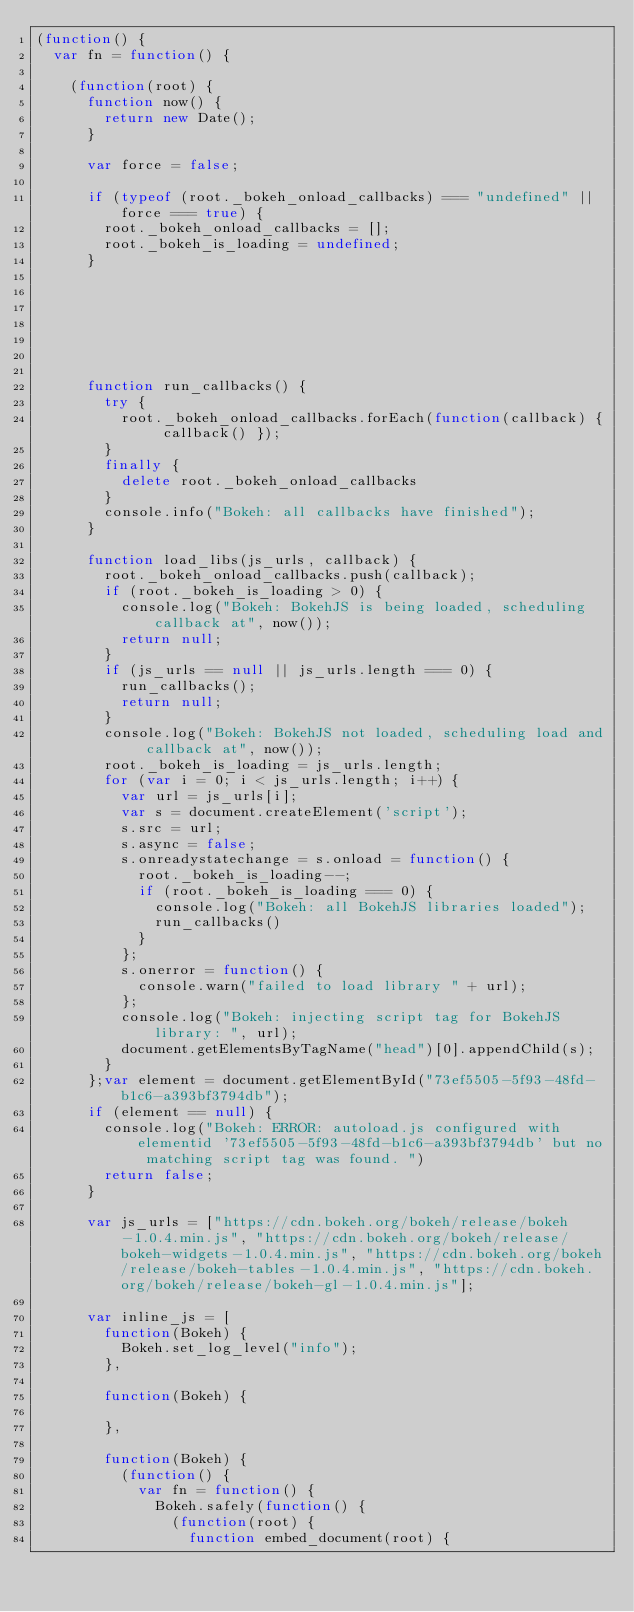<code> <loc_0><loc_0><loc_500><loc_500><_JavaScript_>(function() {
  var fn = function() {
    
    (function(root) {
      function now() {
        return new Date();
      }
    
      var force = false;
    
      if (typeof (root._bokeh_onload_callbacks) === "undefined" || force === true) {
        root._bokeh_onload_callbacks = [];
        root._bokeh_is_loading = undefined;
      }
    
      
      
    
      
      
    
      function run_callbacks() {
        try {
          root._bokeh_onload_callbacks.forEach(function(callback) { callback() });
        }
        finally {
          delete root._bokeh_onload_callbacks
        }
        console.info("Bokeh: all callbacks have finished");
      }
    
      function load_libs(js_urls, callback) {
        root._bokeh_onload_callbacks.push(callback);
        if (root._bokeh_is_loading > 0) {
          console.log("Bokeh: BokehJS is being loaded, scheduling callback at", now());
          return null;
        }
        if (js_urls == null || js_urls.length === 0) {
          run_callbacks();
          return null;
        }
        console.log("Bokeh: BokehJS not loaded, scheduling load and callback at", now());
        root._bokeh_is_loading = js_urls.length;
        for (var i = 0; i < js_urls.length; i++) {
          var url = js_urls[i];
          var s = document.createElement('script');
          s.src = url;
          s.async = false;
          s.onreadystatechange = s.onload = function() {
            root._bokeh_is_loading--;
            if (root._bokeh_is_loading === 0) {
              console.log("Bokeh: all BokehJS libraries loaded");
              run_callbacks()
            }
          };
          s.onerror = function() {
            console.warn("failed to load library " + url);
          };
          console.log("Bokeh: injecting script tag for BokehJS library: ", url);
          document.getElementsByTagName("head")[0].appendChild(s);
        }
      };var element = document.getElementById("73ef5505-5f93-48fd-b1c6-a393bf3794db");
      if (element == null) {
        console.log("Bokeh: ERROR: autoload.js configured with elementid '73ef5505-5f93-48fd-b1c6-a393bf3794db' but no matching script tag was found. ")
        return false;
      }
    
      var js_urls = ["https://cdn.bokeh.org/bokeh/release/bokeh-1.0.4.min.js", "https://cdn.bokeh.org/bokeh/release/bokeh-widgets-1.0.4.min.js", "https://cdn.bokeh.org/bokeh/release/bokeh-tables-1.0.4.min.js", "https://cdn.bokeh.org/bokeh/release/bokeh-gl-1.0.4.min.js"];
    
      var inline_js = [
        function(Bokeh) {
          Bokeh.set_log_level("info");
        },
        
        function(Bokeh) {
          
        },
        
        function(Bokeh) {
          (function() {
            var fn = function() {
              Bokeh.safely(function() {
                (function(root) {
                  function embed_document(root) {
                    </code> 